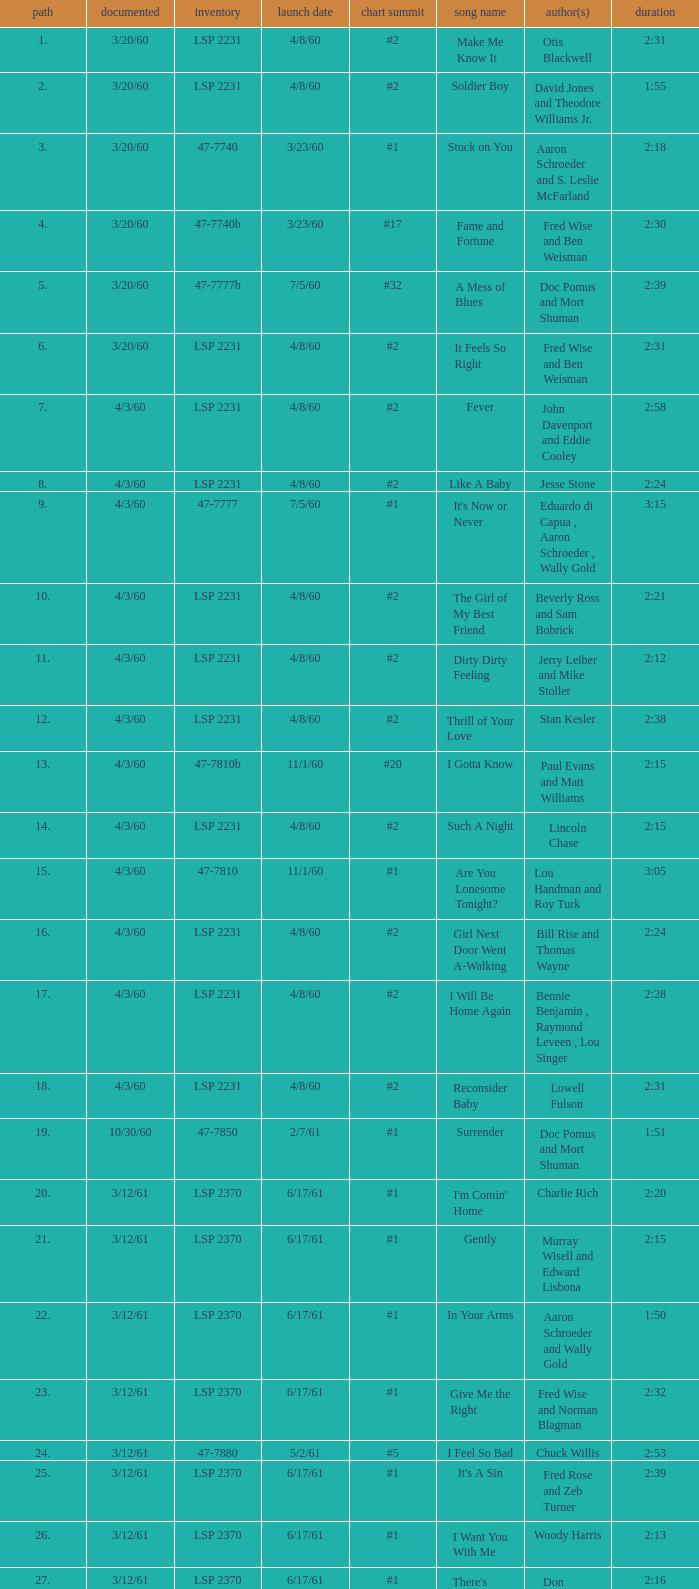What catalogue is the song It's Now or Never? 47-7777. 